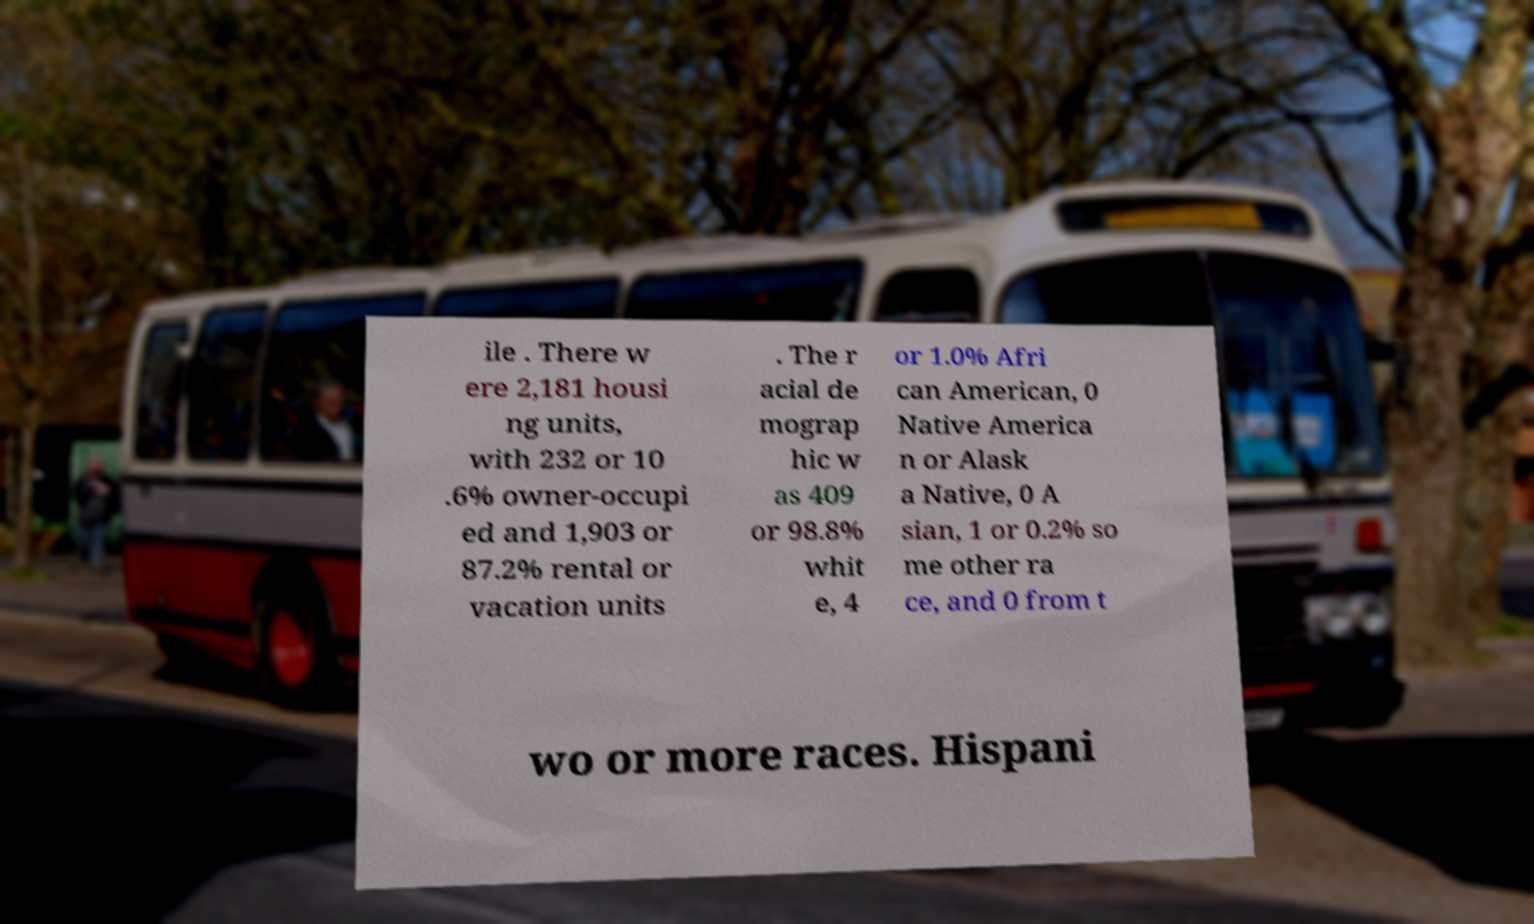Could you assist in decoding the text presented in this image and type it out clearly? ile . There w ere 2,181 housi ng units, with 232 or 10 .6% owner-occupi ed and 1,903 or 87.2% rental or vacation units . The r acial de mograp hic w as 409 or 98.8% whit e, 4 or 1.0% Afri can American, 0 Native America n or Alask a Native, 0 A sian, 1 or 0.2% so me other ra ce, and 0 from t wo or more races. Hispani 